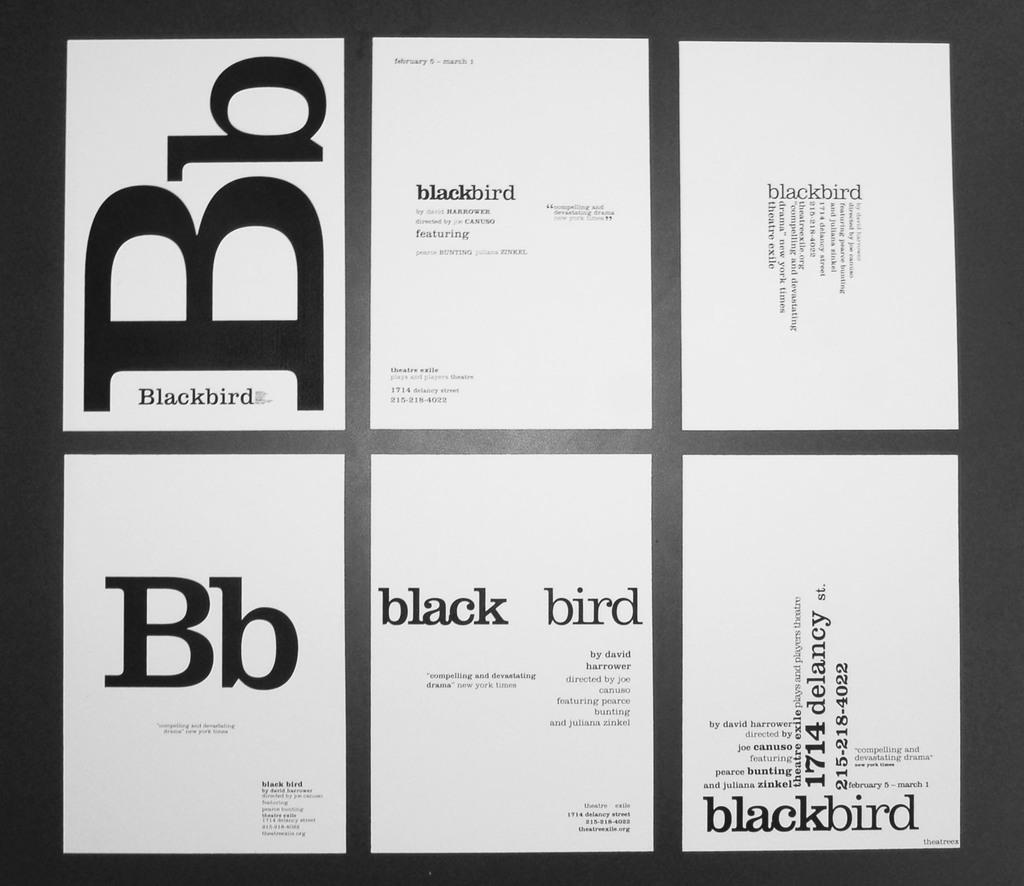What color bird is mentioned?
Your answer should be compact. Black. 